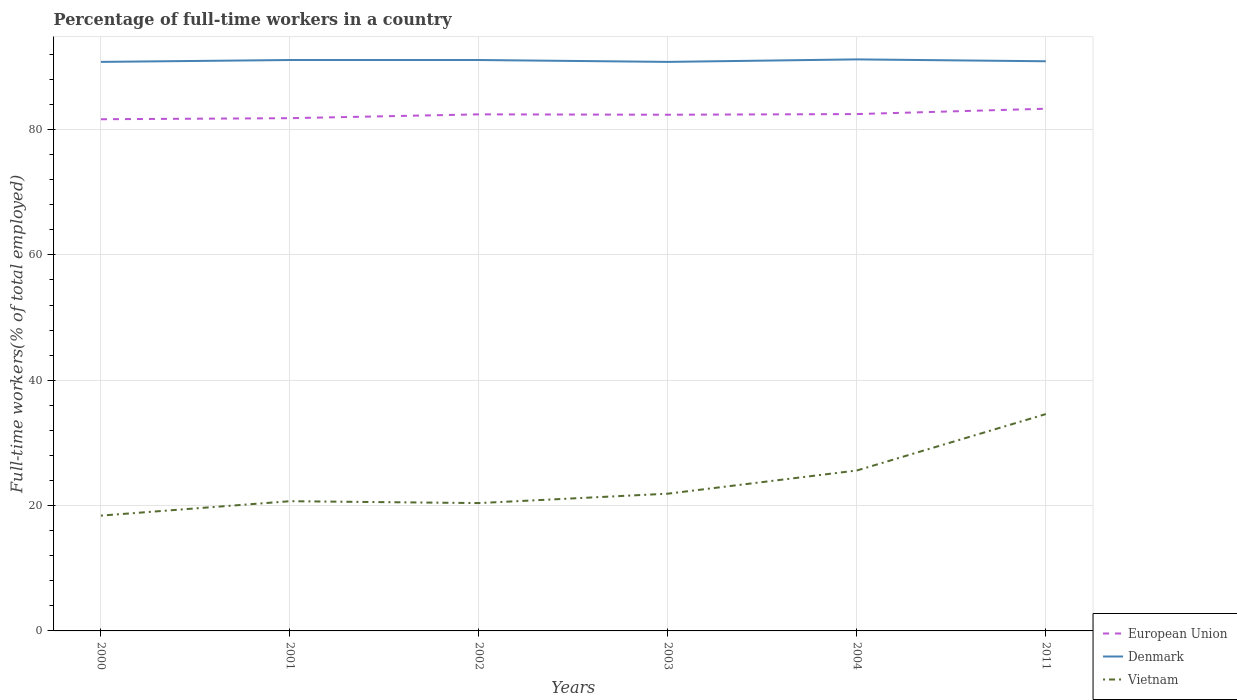Across all years, what is the maximum percentage of full-time workers in Vietnam?
Offer a terse response. 18.4. In which year was the percentage of full-time workers in European Union maximum?
Keep it short and to the point. 2000. What is the total percentage of full-time workers in Vietnam in the graph?
Offer a very short reply. -5.2. What is the difference between the highest and the second highest percentage of full-time workers in Vietnam?
Provide a short and direct response. 16.2. Is the percentage of full-time workers in Vietnam strictly greater than the percentage of full-time workers in Denmark over the years?
Make the answer very short. Yes. What is the difference between two consecutive major ticks on the Y-axis?
Your answer should be compact. 20. Are the values on the major ticks of Y-axis written in scientific E-notation?
Ensure brevity in your answer.  No. Does the graph contain any zero values?
Your response must be concise. No. Where does the legend appear in the graph?
Your answer should be compact. Bottom right. How many legend labels are there?
Offer a very short reply. 3. What is the title of the graph?
Make the answer very short. Percentage of full-time workers in a country. What is the label or title of the X-axis?
Your answer should be very brief. Years. What is the label or title of the Y-axis?
Offer a very short reply. Full-time workers(% of total employed). What is the Full-time workers(% of total employed) of European Union in 2000?
Give a very brief answer. 81.65. What is the Full-time workers(% of total employed) of Denmark in 2000?
Your answer should be compact. 90.8. What is the Full-time workers(% of total employed) of Vietnam in 2000?
Give a very brief answer. 18.4. What is the Full-time workers(% of total employed) of European Union in 2001?
Offer a terse response. 81.82. What is the Full-time workers(% of total employed) in Denmark in 2001?
Provide a short and direct response. 91.1. What is the Full-time workers(% of total employed) in Vietnam in 2001?
Give a very brief answer. 20.7. What is the Full-time workers(% of total employed) of European Union in 2002?
Keep it short and to the point. 82.43. What is the Full-time workers(% of total employed) of Denmark in 2002?
Give a very brief answer. 91.1. What is the Full-time workers(% of total employed) in Vietnam in 2002?
Make the answer very short. 20.4. What is the Full-time workers(% of total employed) of European Union in 2003?
Your answer should be compact. 82.37. What is the Full-time workers(% of total employed) of Denmark in 2003?
Ensure brevity in your answer.  90.8. What is the Full-time workers(% of total employed) of Vietnam in 2003?
Give a very brief answer. 21.9. What is the Full-time workers(% of total employed) of European Union in 2004?
Give a very brief answer. 82.47. What is the Full-time workers(% of total employed) of Denmark in 2004?
Provide a short and direct response. 91.2. What is the Full-time workers(% of total employed) in Vietnam in 2004?
Keep it short and to the point. 25.6. What is the Full-time workers(% of total employed) in European Union in 2011?
Offer a very short reply. 83.33. What is the Full-time workers(% of total employed) in Denmark in 2011?
Provide a short and direct response. 90.9. What is the Full-time workers(% of total employed) in Vietnam in 2011?
Offer a terse response. 34.6. Across all years, what is the maximum Full-time workers(% of total employed) of European Union?
Ensure brevity in your answer.  83.33. Across all years, what is the maximum Full-time workers(% of total employed) of Denmark?
Keep it short and to the point. 91.2. Across all years, what is the maximum Full-time workers(% of total employed) of Vietnam?
Provide a succinct answer. 34.6. Across all years, what is the minimum Full-time workers(% of total employed) of European Union?
Offer a very short reply. 81.65. Across all years, what is the minimum Full-time workers(% of total employed) in Denmark?
Your response must be concise. 90.8. Across all years, what is the minimum Full-time workers(% of total employed) of Vietnam?
Offer a terse response. 18.4. What is the total Full-time workers(% of total employed) of European Union in the graph?
Your response must be concise. 494.07. What is the total Full-time workers(% of total employed) in Denmark in the graph?
Make the answer very short. 545.9. What is the total Full-time workers(% of total employed) in Vietnam in the graph?
Provide a short and direct response. 141.6. What is the difference between the Full-time workers(% of total employed) in European Union in 2000 and that in 2001?
Offer a very short reply. -0.17. What is the difference between the Full-time workers(% of total employed) of Denmark in 2000 and that in 2001?
Your answer should be very brief. -0.3. What is the difference between the Full-time workers(% of total employed) of European Union in 2000 and that in 2002?
Provide a succinct answer. -0.78. What is the difference between the Full-time workers(% of total employed) of Vietnam in 2000 and that in 2002?
Your response must be concise. -2. What is the difference between the Full-time workers(% of total employed) of European Union in 2000 and that in 2003?
Ensure brevity in your answer.  -0.72. What is the difference between the Full-time workers(% of total employed) in European Union in 2000 and that in 2004?
Offer a terse response. -0.82. What is the difference between the Full-time workers(% of total employed) in European Union in 2000 and that in 2011?
Ensure brevity in your answer.  -1.68. What is the difference between the Full-time workers(% of total employed) of Denmark in 2000 and that in 2011?
Keep it short and to the point. -0.1. What is the difference between the Full-time workers(% of total employed) of Vietnam in 2000 and that in 2011?
Your answer should be compact. -16.2. What is the difference between the Full-time workers(% of total employed) in European Union in 2001 and that in 2002?
Provide a succinct answer. -0.61. What is the difference between the Full-time workers(% of total employed) of Denmark in 2001 and that in 2002?
Keep it short and to the point. 0. What is the difference between the Full-time workers(% of total employed) in Vietnam in 2001 and that in 2002?
Offer a very short reply. 0.3. What is the difference between the Full-time workers(% of total employed) in European Union in 2001 and that in 2003?
Ensure brevity in your answer.  -0.55. What is the difference between the Full-time workers(% of total employed) in Denmark in 2001 and that in 2003?
Keep it short and to the point. 0.3. What is the difference between the Full-time workers(% of total employed) in European Union in 2001 and that in 2004?
Offer a terse response. -0.66. What is the difference between the Full-time workers(% of total employed) in European Union in 2001 and that in 2011?
Provide a short and direct response. -1.51. What is the difference between the Full-time workers(% of total employed) of European Union in 2002 and that in 2003?
Your answer should be compact. 0.06. What is the difference between the Full-time workers(% of total employed) in Vietnam in 2002 and that in 2003?
Keep it short and to the point. -1.5. What is the difference between the Full-time workers(% of total employed) of European Union in 2002 and that in 2004?
Provide a succinct answer. -0.04. What is the difference between the Full-time workers(% of total employed) in Denmark in 2002 and that in 2004?
Ensure brevity in your answer.  -0.1. What is the difference between the Full-time workers(% of total employed) of European Union in 2002 and that in 2011?
Provide a short and direct response. -0.9. What is the difference between the Full-time workers(% of total employed) of Denmark in 2002 and that in 2011?
Keep it short and to the point. 0.2. What is the difference between the Full-time workers(% of total employed) in Vietnam in 2002 and that in 2011?
Your response must be concise. -14.2. What is the difference between the Full-time workers(% of total employed) in European Union in 2003 and that in 2004?
Your answer should be compact. -0.11. What is the difference between the Full-time workers(% of total employed) in Vietnam in 2003 and that in 2004?
Your response must be concise. -3.7. What is the difference between the Full-time workers(% of total employed) of European Union in 2003 and that in 2011?
Provide a short and direct response. -0.96. What is the difference between the Full-time workers(% of total employed) of Denmark in 2003 and that in 2011?
Your response must be concise. -0.1. What is the difference between the Full-time workers(% of total employed) in European Union in 2004 and that in 2011?
Provide a short and direct response. -0.85. What is the difference between the Full-time workers(% of total employed) in European Union in 2000 and the Full-time workers(% of total employed) in Denmark in 2001?
Offer a very short reply. -9.45. What is the difference between the Full-time workers(% of total employed) in European Union in 2000 and the Full-time workers(% of total employed) in Vietnam in 2001?
Make the answer very short. 60.95. What is the difference between the Full-time workers(% of total employed) in Denmark in 2000 and the Full-time workers(% of total employed) in Vietnam in 2001?
Make the answer very short. 70.1. What is the difference between the Full-time workers(% of total employed) in European Union in 2000 and the Full-time workers(% of total employed) in Denmark in 2002?
Keep it short and to the point. -9.45. What is the difference between the Full-time workers(% of total employed) in European Union in 2000 and the Full-time workers(% of total employed) in Vietnam in 2002?
Make the answer very short. 61.25. What is the difference between the Full-time workers(% of total employed) in Denmark in 2000 and the Full-time workers(% of total employed) in Vietnam in 2002?
Provide a short and direct response. 70.4. What is the difference between the Full-time workers(% of total employed) in European Union in 2000 and the Full-time workers(% of total employed) in Denmark in 2003?
Offer a very short reply. -9.15. What is the difference between the Full-time workers(% of total employed) in European Union in 2000 and the Full-time workers(% of total employed) in Vietnam in 2003?
Offer a terse response. 59.75. What is the difference between the Full-time workers(% of total employed) in Denmark in 2000 and the Full-time workers(% of total employed) in Vietnam in 2003?
Keep it short and to the point. 68.9. What is the difference between the Full-time workers(% of total employed) in European Union in 2000 and the Full-time workers(% of total employed) in Denmark in 2004?
Keep it short and to the point. -9.55. What is the difference between the Full-time workers(% of total employed) of European Union in 2000 and the Full-time workers(% of total employed) of Vietnam in 2004?
Your answer should be very brief. 56.05. What is the difference between the Full-time workers(% of total employed) of Denmark in 2000 and the Full-time workers(% of total employed) of Vietnam in 2004?
Offer a very short reply. 65.2. What is the difference between the Full-time workers(% of total employed) in European Union in 2000 and the Full-time workers(% of total employed) in Denmark in 2011?
Your response must be concise. -9.25. What is the difference between the Full-time workers(% of total employed) in European Union in 2000 and the Full-time workers(% of total employed) in Vietnam in 2011?
Your answer should be compact. 47.05. What is the difference between the Full-time workers(% of total employed) of Denmark in 2000 and the Full-time workers(% of total employed) of Vietnam in 2011?
Keep it short and to the point. 56.2. What is the difference between the Full-time workers(% of total employed) in European Union in 2001 and the Full-time workers(% of total employed) in Denmark in 2002?
Ensure brevity in your answer.  -9.28. What is the difference between the Full-time workers(% of total employed) in European Union in 2001 and the Full-time workers(% of total employed) in Vietnam in 2002?
Provide a short and direct response. 61.42. What is the difference between the Full-time workers(% of total employed) of Denmark in 2001 and the Full-time workers(% of total employed) of Vietnam in 2002?
Your answer should be compact. 70.7. What is the difference between the Full-time workers(% of total employed) in European Union in 2001 and the Full-time workers(% of total employed) in Denmark in 2003?
Your response must be concise. -8.98. What is the difference between the Full-time workers(% of total employed) in European Union in 2001 and the Full-time workers(% of total employed) in Vietnam in 2003?
Ensure brevity in your answer.  59.92. What is the difference between the Full-time workers(% of total employed) of Denmark in 2001 and the Full-time workers(% of total employed) of Vietnam in 2003?
Your response must be concise. 69.2. What is the difference between the Full-time workers(% of total employed) of European Union in 2001 and the Full-time workers(% of total employed) of Denmark in 2004?
Your response must be concise. -9.38. What is the difference between the Full-time workers(% of total employed) of European Union in 2001 and the Full-time workers(% of total employed) of Vietnam in 2004?
Your response must be concise. 56.22. What is the difference between the Full-time workers(% of total employed) of Denmark in 2001 and the Full-time workers(% of total employed) of Vietnam in 2004?
Your answer should be very brief. 65.5. What is the difference between the Full-time workers(% of total employed) of European Union in 2001 and the Full-time workers(% of total employed) of Denmark in 2011?
Keep it short and to the point. -9.08. What is the difference between the Full-time workers(% of total employed) in European Union in 2001 and the Full-time workers(% of total employed) in Vietnam in 2011?
Offer a terse response. 47.22. What is the difference between the Full-time workers(% of total employed) of Denmark in 2001 and the Full-time workers(% of total employed) of Vietnam in 2011?
Keep it short and to the point. 56.5. What is the difference between the Full-time workers(% of total employed) in European Union in 2002 and the Full-time workers(% of total employed) in Denmark in 2003?
Your answer should be compact. -8.37. What is the difference between the Full-time workers(% of total employed) in European Union in 2002 and the Full-time workers(% of total employed) in Vietnam in 2003?
Keep it short and to the point. 60.53. What is the difference between the Full-time workers(% of total employed) in Denmark in 2002 and the Full-time workers(% of total employed) in Vietnam in 2003?
Ensure brevity in your answer.  69.2. What is the difference between the Full-time workers(% of total employed) of European Union in 2002 and the Full-time workers(% of total employed) of Denmark in 2004?
Offer a terse response. -8.77. What is the difference between the Full-time workers(% of total employed) of European Union in 2002 and the Full-time workers(% of total employed) of Vietnam in 2004?
Your answer should be very brief. 56.83. What is the difference between the Full-time workers(% of total employed) in Denmark in 2002 and the Full-time workers(% of total employed) in Vietnam in 2004?
Make the answer very short. 65.5. What is the difference between the Full-time workers(% of total employed) in European Union in 2002 and the Full-time workers(% of total employed) in Denmark in 2011?
Offer a very short reply. -8.47. What is the difference between the Full-time workers(% of total employed) of European Union in 2002 and the Full-time workers(% of total employed) of Vietnam in 2011?
Provide a short and direct response. 47.83. What is the difference between the Full-time workers(% of total employed) in Denmark in 2002 and the Full-time workers(% of total employed) in Vietnam in 2011?
Give a very brief answer. 56.5. What is the difference between the Full-time workers(% of total employed) in European Union in 2003 and the Full-time workers(% of total employed) in Denmark in 2004?
Your answer should be compact. -8.83. What is the difference between the Full-time workers(% of total employed) in European Union in 2003 and the Full-time workers(% of total employed) in Vietnam in 2004?
Ensure brevity in your answer.  56.77. What is the difference between the Full-time workers(% of total employed) of Denmark in 2003 and the Full-time workers(% of total employed) of Vietnam in 2004?
Your answer should be compact. 65.2. What is the difference between the Full-time workers(% of total employed) in European Union in 2003 and the Full-time workers(% of total employed) in Denmark in 2011?
Give a very brief answer. -8.53. What is the difference between the Full-time workers(% of total employed) of European Union in 2003 and the Full-time workers(% of total employed) of Vietnam in 2011?
Offer a very short reply. 47.77. What is the difference between the Full-time workers(% of total employed) in Denmark in 2003 and the Full-time workers(% of total employed) in Vietnam in 2011?
Your response must be concise. 56.2. What is the difference between the Full-time workers(% of total employed) of European Union in 2004 and the Full-time workers(% of total employed) of Denmark in 2011?
Offer a terse response. -8.43. What is the difference between the Full-time workers(% of total employed) in European Union in 2004 and the Full-time workers(% of total employed) in Vietnam in 2011?
Provide a succinct answer. 47.87. What is the difference between the Full-time workers(% of total employed) in Denmark in 2004 and the Full-time workers(% of total employed) in Vietnam in 2011?
Provide a succinct answer. 56.6. What is the average Full-time workers(% of total employed) of European Union per year?
Provide a succinct answer. 82.34. What is the average Full-time workers(% of total employed) in Denmark per year?
Give a very brief answer. 90.98. What is the average Full-time workers(% of total employed) in Vietnam per year?
Offer a terse response. 23.6. In the year 2000, what is the difference between the Full-time workers(% of total employed) of European Union and Full-time workers(% of total employed) of Denmark?
Give a very brief answer. -9.15. In the year 2000, what is the difference between the Full-time workers(% of total employed) of European Union and Full-time workers(% of total employed) of Vietnam?
Your answer should be very brief. 63.25. In the year 2000, what is the difference between the Full-time workers(% of total employed) of Denmark and Full-time workers(% of total employed) of Vietnam?
Provide a short and direct response. 72.4. In the year 2001, what is the difference between the Full-time workers(% of total employed) of European Union and Full-time workers(% of total employed) of Denmark?
Offer a very short reply. -9.28. In the year 2001, what is the difference between the Full-time workers(% of total employed) of European Union and Full-time workers(% of total employed) of Vietnam?
Your answer should be very brief. 61.12. In the year 2001, what is the difference between the Full-time workers(% of total employed) in Denmark and Full-time workers(% of total employed) in Vietnam?
Provide a succinct answer. 70.4. In the year 2002, what is the difference between the Full-time workers(% of total employed) of European Union and Full-time workers(% of total employed) of Denmark?
Make the answer very short. -8.67. In the year 2002, what is the difference between the Full-time workers(% of total employed) of European Union and Full-time workers(% of total employed) of Vietnam?
Your response must be concise. 62.03. In the year 2002, what is the difference between the Full-time workers(% of total employed) in Denmark and Full-time workers(% of total employed) in Vietnam?
Provide a short and direct response. 70.7. In the year 2003, what is the difference between the Full-time workers(% of total employed) in European Union and Full-time workers(% of total employed) in Denmark?
Offer a very short reply. -8.43. In the year 2003, what is the difference between the Full-time workers(% of total employed) of European Union and Full-time workers(% of total employed) of Vietnam?
Your answer should be very brief. 60.47. In the year 2003, what is the difference between the Full-time workers(% of total employed) in Denmark and Full-time workers(% of total employed) in Vietnam?
Ensure brevity in your answer.  68.9. In the year 2004, what is the difference between the Full-time workers(% of total employed) of European Union and Full-time workers(% of total employed) of Denmark?
Your answer should be very brief. -8.73. In the year 2004, what is the difference between the Full-time workers(% of total employed) in European Union and Full-time workers(% of total employed) in Vietnam?
Provide a succinct answer. 56.87. In the year 2004, what is the difference between the Full-time workers(% of total employed) of Denmark and Full-time workers(% of total employed) of Vietnam?
Give a very brief answer. 65.6. In the year 2011, what is the difference between the Full-time workers(% of total employed) of European Union and Full-time workers(% of total employed) of Denmark?
Offer a terse response. -7.57. In the year 2011, what is the difference between the Full-time workers(% of total employed) in European Union and Full-time workers(% of total employed) in Vietnam?
Your answer should be compact. 48.73. In the year 2011, what is the difference between the Full-time workers(% of total employed) in Denmark and Full-time workers(% of total employed) in Vietnam?
Give a very brief answer. 56.3. What is the ratio of the Full-time workers(% of total employed) in European Union in 2000 to that in 2001?
Give a very brief answer. 1. What is the ratio of the Full-time workers(% of total employed) of Denmark in 2000 to that in 2001?
Ensure brevity in your answer.  1. What is the ratio of the Full-time workers(% of total employed) of Vietnam in 2000 to that in 2002?
Keep it short and to the point. 0.9. What is the ratio of the Full-time workers(% of total employed) in Denmark in 2000 to that in 2003?
Give a very brief answer. 1. What is the ratio of the Full-time workers(% of total employed) in Vietnam in 2000 to that in 2003?
Your answer should be compact. 0.84. What is the ratio of the Full-time workers(% of total employed) of Vietnam in 2000 to that in 2004?
Give a very brief answer. 0.72. What is the ratio of the Full-time workers(% of total employed) of European Union in 2000 to that in 2011?
Give a very brief answer. 0.98. What is the ratio of the Full-time workers(% of total employed) in Vietnam in 2000 to that in 2011?
Offer a very short reply. 0.53. What is the ratio of the Full-time workers(% of total employed) of European Union in 2001 to that in 2002?
Make the answer very short. 0.99. What is the ratio of the Full-time workers(% of total employed) of Vietnam in 2001 to that in 2002?
Your response must be concise. 1.01. What is the ratio of the Full-time workers(% of total employed) in Vietnam in 2001 to that in 2003?
Keep it short and to the point. 0.95. What is the ratio of the Full-time workers(% of total employed) of Denmark in 2001 to that in 2004?
Your answer should be compact. 1. What is the ratio of the Full-time workers(% of total employed) in Vietnam in 2001 to that in 2004?
Provide a succinct answer. 0.81. What is the ratio of the Full-time workers(% of total employed) in European Union in 2001 to that in 2011?
Your answer should be very brief. 0.98. What is the ratio of the Full-time workers(% of total employed) in Denmark in 2001 to that in 2011?
Give a very brief answer. 1. What is the ratio of the Full-time workers(% of total employed) in Vietnam in 2001 to that in 2011?
Offer a very short reply. 0.6. What is the ratio of the Full-time workers(% of total employed) in European Union in 2002 to that in 2003?
Provide a short and direct response. 1. What is the ratio of the Full-time workers(% of total employed) of Denmark in 2002 to that in 2003?
Provide a succinct answer. 1. What is the ratio of the Full-time workers(% of total employed) of Vietnam in 2002 to that in 2003?
Offer a terse response. 0.93. What is the ratio of the Full-time workers(% of total employed) in Denmark in 2002 to that in 2004?
Make the answer very short. 1. What is the ratio of the Full-time workers(% of total employed) of Vietnam in 2002 to that in 2004?
Offer a very short reply. 0.8. What is the ratio of the Full-time workers(% of total employed) in European Union in 2002 to that in 2011?
Offer a terse response. 0.99. What is the ratio of the Full-time workers(% of total employed) in Vietnam in 2002 to that in 2011?
Your response must be concise. 0.59. What is the ratio of the Full-time workers(% of total employed) in European Union in 2003 to that in 2004?
Give a very brief answer. 1. What is the ratio of the Full-time workers(% of total employed) of Vietnam in 2003 to that in 2004?
Offer a terse response. 0.86. What is the ratio of the Full-time workers(% of total employed) in European Union in 2003 to that in 2011?
Your answer should be very brief. 0.99. What is the ratio of the Full-time workers(% of total employed) in Denmark in 2003 to that in 2011?
Ensure brevity in your answer.  1. What is the ratio of the Full-time workers(% of total employed) of Vietnam in 2003 to that in 2011?
Your answer should be compact. 0.63. What is the ratio of the Full-time workers(% of total employed) in Vietnam in 2004 to that in 2011?
Keep it short and to the point. 0.74. What is the difference between the highest and the second highest Full-time workers(% of total employed) of European Union?
Offer a terse response. 0.85. What is the difference between the highest and the second highest Full-time workers(% of total employed) of Denmark?
Keep it short and to the point. 0.1. What is the difference between the highest and the lowest Full-time workers(% of total employed) of European Union?
Provide a succinct answer. 1.68. What is the difference between the highest and the lowest Full-time workers(% of total employed) of Denmark?
Offer a terse response. 0.4. 